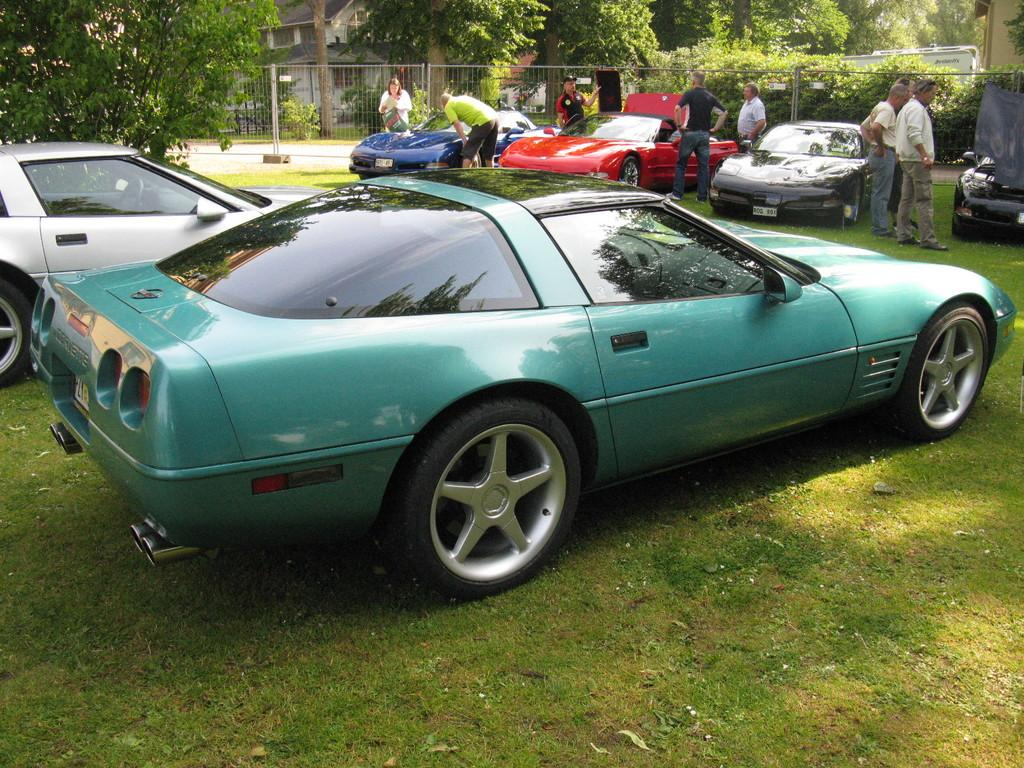How many cars are present in the image? There are 6 cars in the image. What can be observed about the colors of the cars? The cars are of different colors. Can you describe the people near the cars? There are people near the cars, but their specific actions or characteristics are not mentioned in the facts. What type of vegetation is visible in the image? There is green grass in the image. What can be seen in the background of the image? There are trees, buildings, and a path visible in the background of the image. What type of creature is holding the thread while sneezing in the image? There is no creature or thread present in the image, and no one is sneezing. 